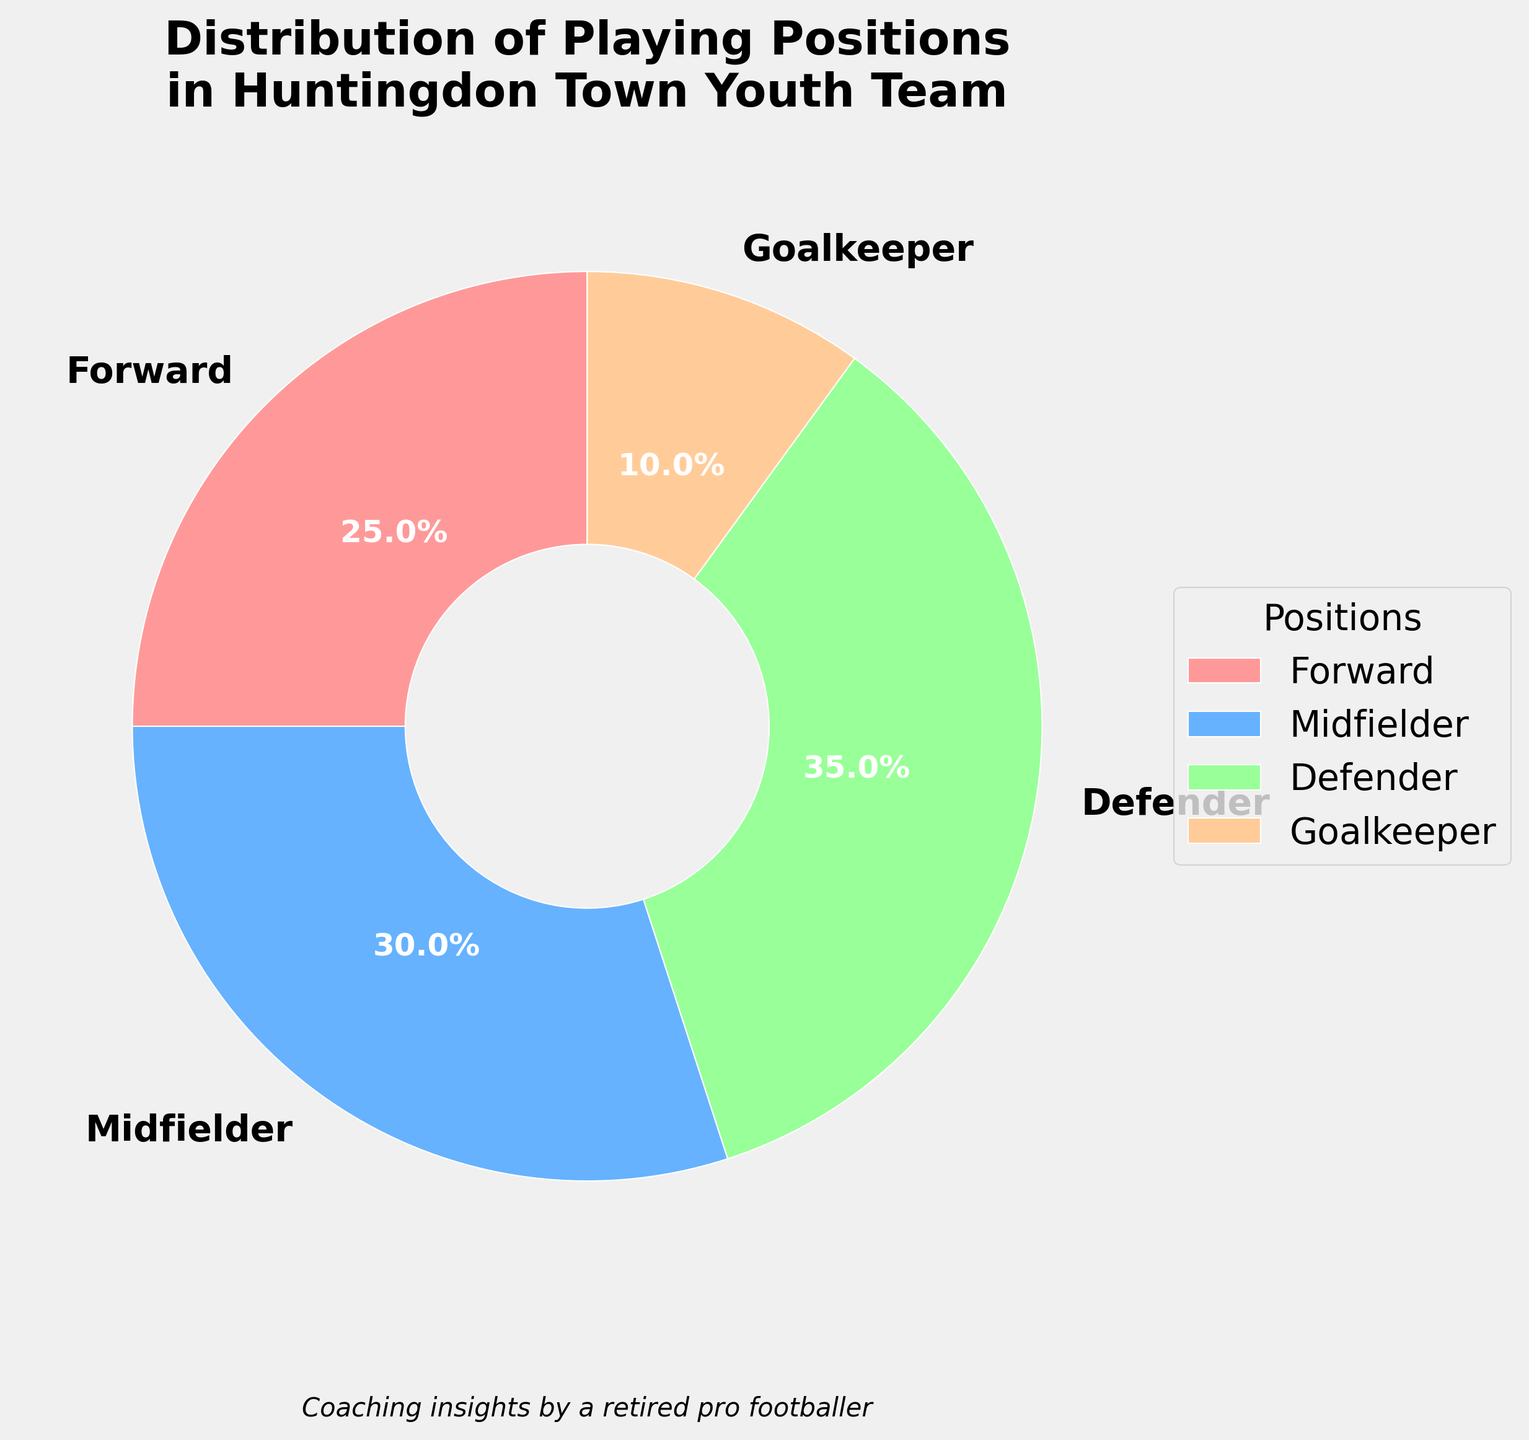Which playing position has the highest percentage? By examining the pie chart, we can see that the 'Defender' section of the chart is the largest, indicating that it has the highest percentage.
Answer: Defender What is the combined percentage of Forwards and Midfielders? To find the combined percentage, add the percentage of Forwards (25%) and Midfielders (30%): 25% + 30% = 55%.
Answer: 55% Which position occupies the smallest slice of the pie chart? The smallest slice of the pie chart corresponds to the 'Goalkeeper' section, indicating it has the lowest percentage.
Answer: Goalkeeper How much greater is the percentage of Defenders compared to Goalkeepers? The Defenders have a percentage of 35% and Goalkeepers have 10%. Subtract the Goalkeeper percentage from the Defender percentage: 35% - 10% = 25%.
Answer: 25% Which position shares the most similar percentage with the Goalkeepers? By comparing the percentages, the Goalkeepers have 10%, and the closest percentage is the Forwards with 25%. The difference in visual size is also quite noticeable.
Answer: Forwards What is the average percentage of all the playing positions? Sum the percentages for all positions: 25% (Forward) + 30% (Midfielder) + 35% (Defender) + 10% (Goalkeeper) = 100%. Divide by the number of positions (4): 100% / 4 = 25%.
Answer: 25% Compare the proportion of Forwards to Midfielders. Which is higher and by how much? The pie chart shows Forwards at 25% and Midfielders at 30%. Subtract the Forward percentage from the Midfielder percentage: 30% - 25% = 5%. The Midfielders have a higher proportion by 5%.
Answer: Midfielders, 5% If we combine the percentages of Defenders and Midfielders, what fraction of the total team do they represent? Sum the percentages of Defenders (35%) and Midfielders (30%): 35% + 30% = 65%. Since these percentages are out of 100%, they represent 65/100 or 65% of the total team.
Answer: 65% 